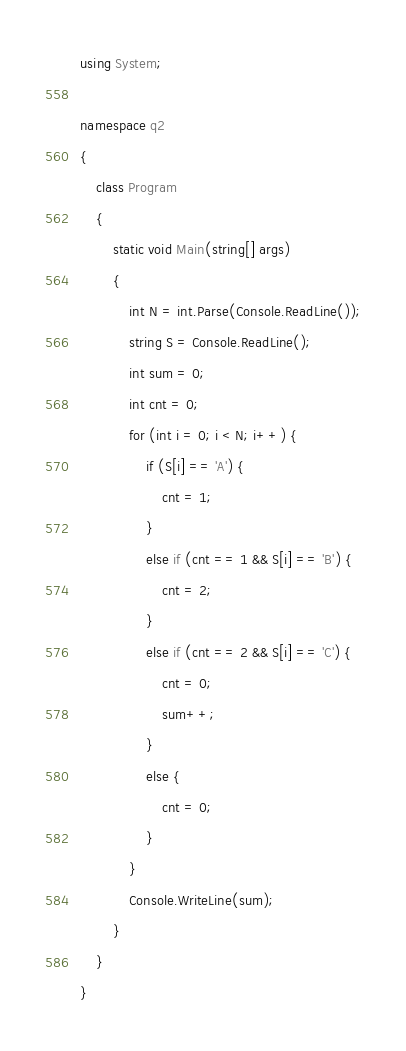Convert code to text. <code><loc_0><loc_0><loc_500><loc_500><_C#_>using System;

namespace q2
{
    class Program
    {
        static void Main(string[] args)
        {
            int N = int.Parse(Console.ReadLine());
            string S = Console.ReadLine();
            int sum = 0;
            int cnt = 0;
            for (int i = 0; i < N; i++) {
                if (S[i] == 'A') {
                    cnt = 1;
                }
                else if (cnt == 1 && S[i] == 'B') {
                    cnt = 2;
                }
                else if (cnt == 2 && S[i] == 'C') {
                    cnt = 0;
                    sum++;
                }
                else {
                    cnt = 0;
                }
            }
            Console.WriteLine(sum);
        }
    }
}
</code> 